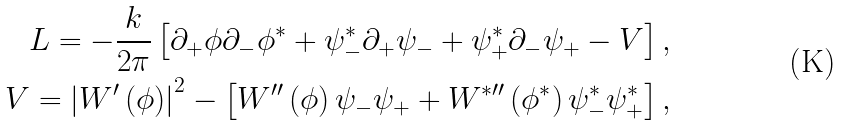<formula> <loc_0><loc_0><loc_500><loc_500>L = - \frac { k } { 2 \pi } \left [ \partial _ { + } \phi \partial _ { - } \phi ^ { \ast } + \psi _ { - } ^ { \ast } \partial _ { + } \psi _ { - } + \psi _ { + } ^ { \ast } \partial _ { - } \psi _ { + } - V \right ] , \\ V = \left | W ^ { \prime } \left ( \phi \right ) \right | ^ { 2 } - \left [ W ^ { \prime \prime } \left ( \phi \right ) \psi _ { - } \psi _ { + } + W ^ { \ast \prime \prime } \left ( \phi ^ { \ast } \right ) \psi _ { - } ^ { \ast } \psi _ { + } ^ { \ast } \right ] ,</formula> 